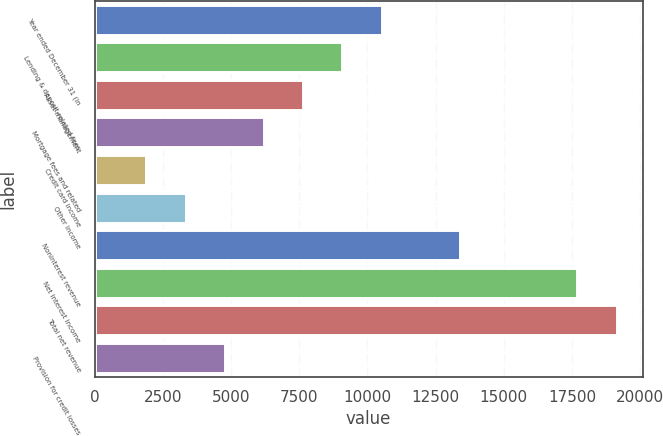<chart> <loc_0><loc_0><loc_500><loc_500><bar_chart><fcel>Year ended December 31 (in<fcel>Lending & deposit-related fees<fcel>Asset management<fcel>Mortgage fees and related<fcel>Credit card income<fcel>Other income<fcel>Noninterest revenue<fcel>Net interest income<fcel>Total net revenue<fcel>Provision for credit losses<nl><fcel>10516.7<fcel>9080.6<fcel>7644.5<fcel>6208.4<fcel>1900.1<fcel>3336.2<fcel>13388.9<fcel>17697.2<fcel>19133.3<fcel>4772.3<nl></chart> 